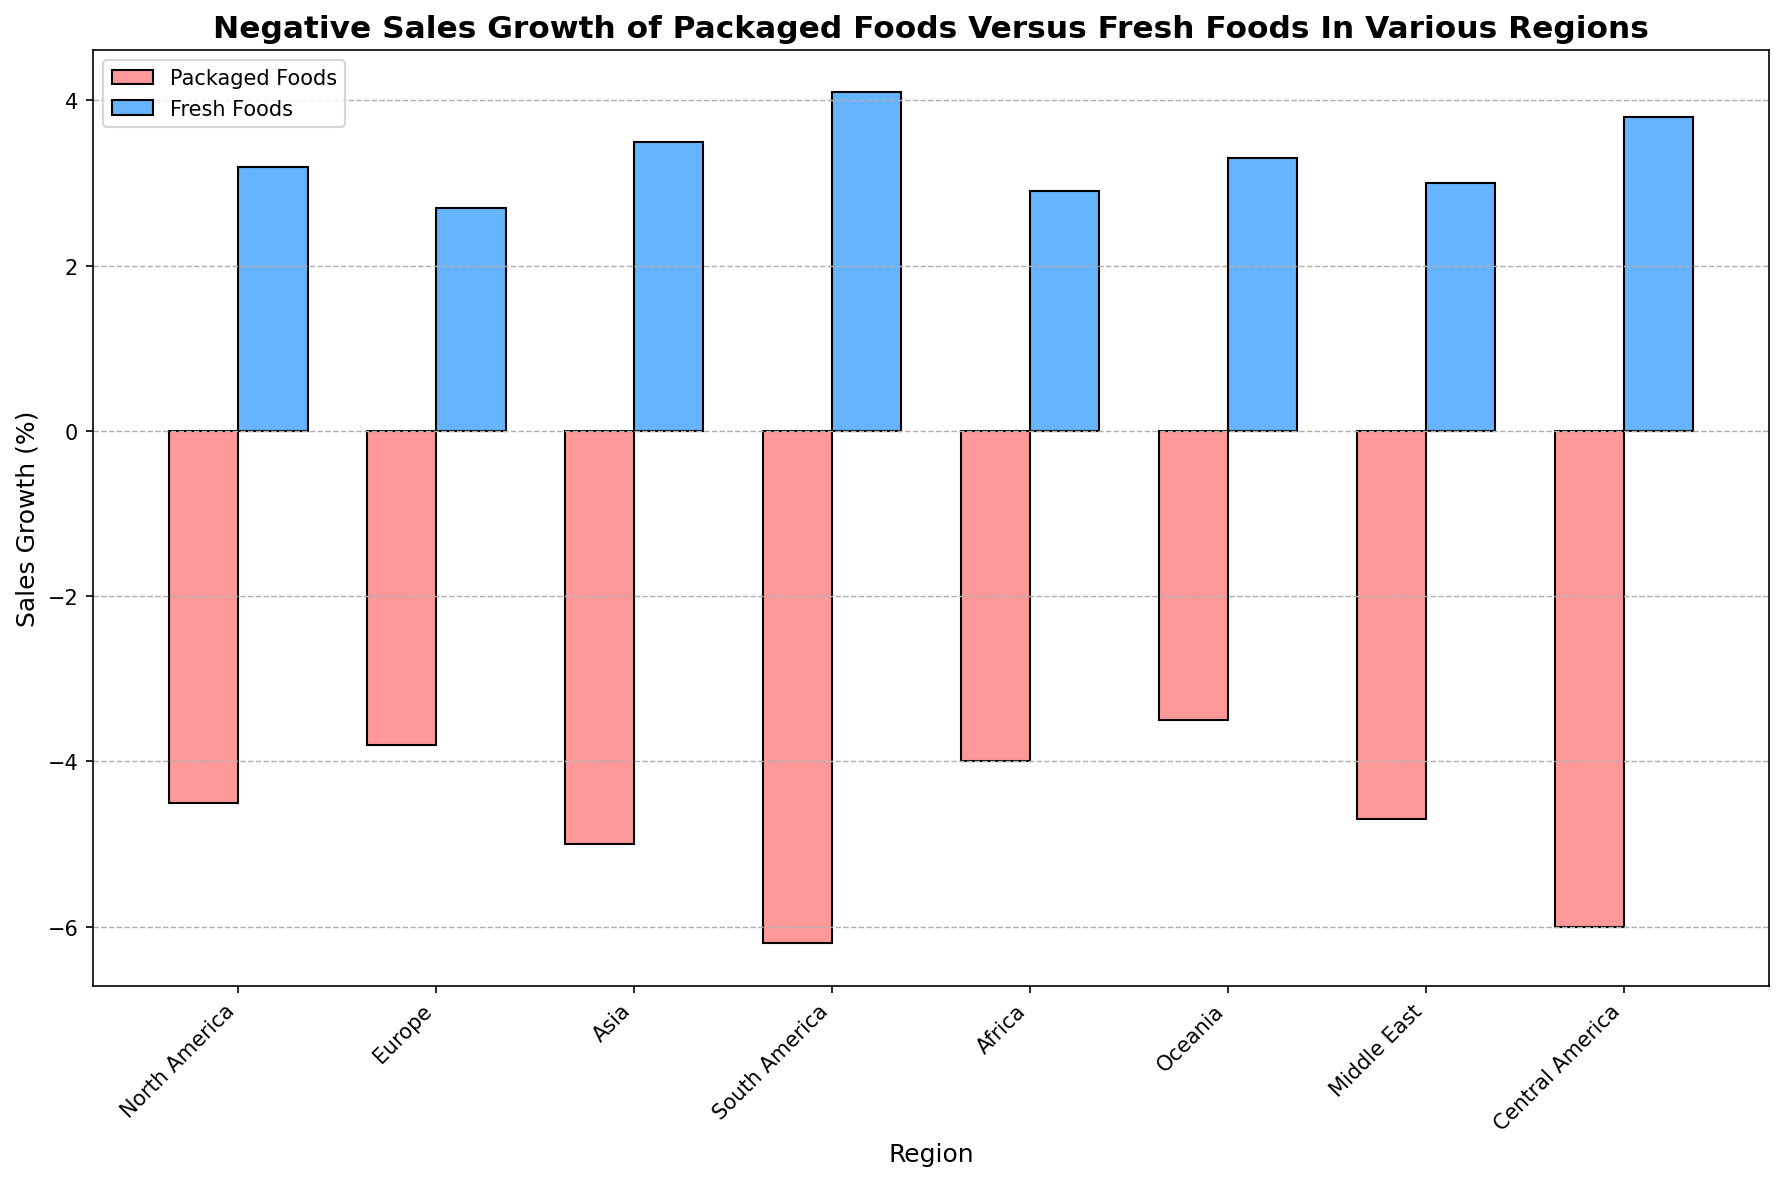Which region has the highest negative sales growth for packaged foods? The bar representing Packaged Foods for South America has the lowest (most negative) value at -6.2%.
Answer: South America Which region has the highest positive sales growth for fresh foods? The bar representing Fresh Foods for South America has the highest positive value at 4.1%.
Answer: South America What is the difference in sales growth between packaged foods and fresh foods in Asia? The sales growth for Packaged Foods in Asia is -5.0% and for Fresh Foods is 3.5%. The difference is calculated as 3.5 - (-5.0) = 3.5 + 5.0 = 8.5%.
Answer: 8.5% Which region has the smallest negative sales growth for packaged foods? Oceania has the smallest negative value for Packaged Foods at -3.5%.
Answer: Oceania Which region shows a higher sales growth for fresh foods: Central America or the Middle East? The sales growth for Fresh Foods in Central America is 3.8%, while in the Middle East it is 3.0%. Comparing these, 3.8% is higher than 3.0%.
Answer: Central America What is the average negative sales growth of packaged foods across all regions? The sum of the negative sales growth percentages for Packaged Foods across all regions is (-4.5) + (-3.8) + (-5.0) + (-6.2) + (-4.0) + (-3.5) + (-4.7) + (-6.0) = -37.7. Dividing this sum by the number of regions (8) gives -37.7 / 8 = -4.71%.
Answer: -4.71% Which has a greater range in sales growth, packaged foods or fresh foods? The range for Packaged Foods is calculated by subtracting the smallest value (-6.2) from the largest value (-3.5), giving a range of -3.5 - (-6.2) = 2.7%. For Fresh Foods, subtract the smallest positive value (2.7) from the largest positive value (4.1), giving a range of 4.1 - 2.7 = 1.4%. The range for Packaged Foods is greater.
Answer: Packaged Foods What is the total positive sales growth for fresh foods across all regions? Sum the positive sales growth percentages for Fresh Foods across all regions: 3.2 + 2.7 + 3.5 + 4.1 + 2.9 + 3.3 + 3.0 + 3.8 = 26.5%.
Answer: 26.5% What is the combined sales growth (packaged + fresh) for North America? The sales growth for Packaged Foods in North America is -4.5% and for Fresh Foods is 3.2%. The combined growth is -4.5 + 3.2 = -1.3%.
Answer: -1.3% 